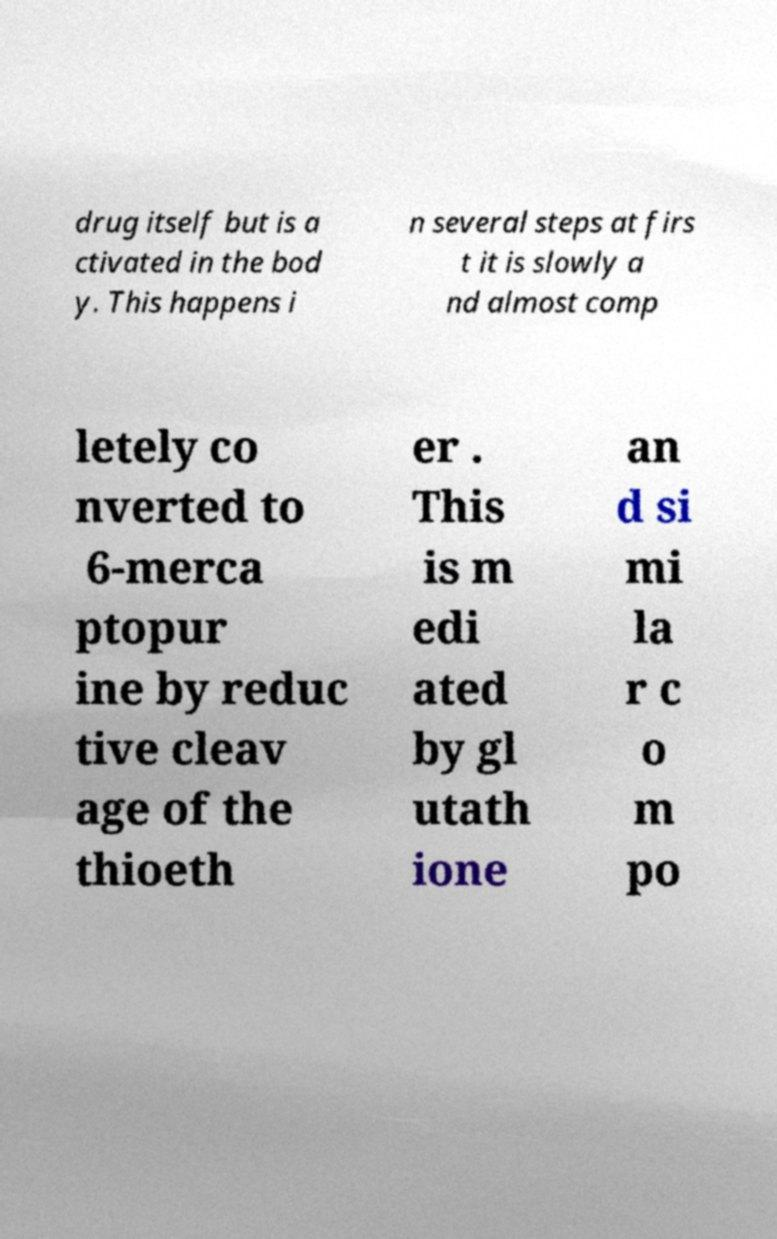Please read and relay the text visible in this image. What does it say? drug itself but is a ctivated in the bod y. This happens i n several steps at firs t it is slowly a nd almost comp letely co nverted to 6-merca ptopur ine by reduc tive cleav age of the thioeth er . This is m edi ated by gl utath ione an d si mi la r c o m po 